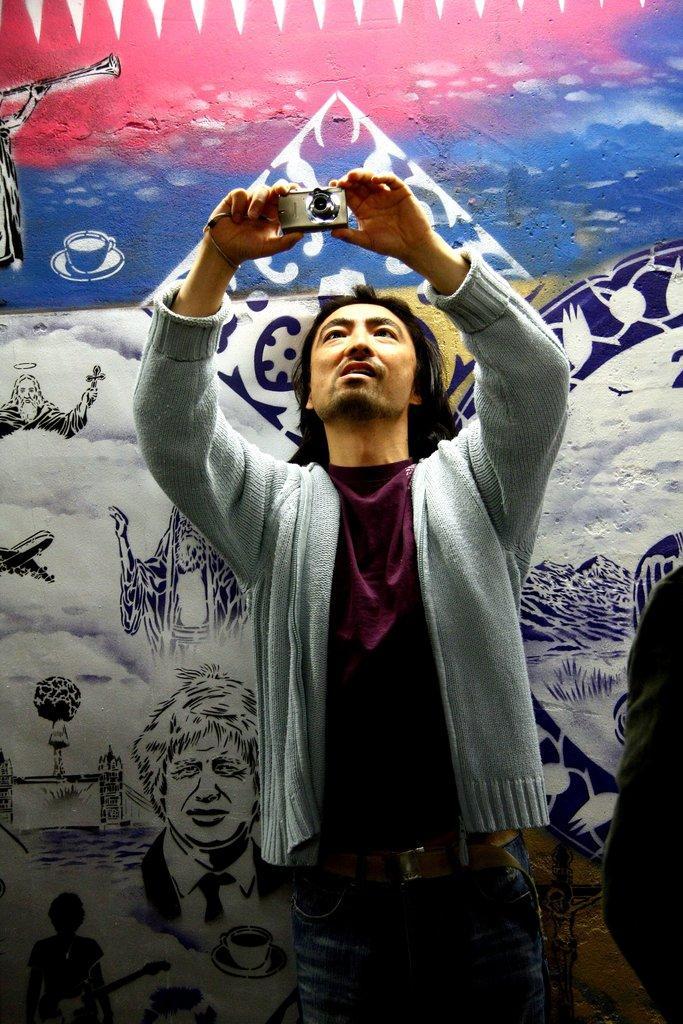Could you give a brief overview of what you see in this image? In this image there is a person standing and holding camera in his hands, in the background there is a wall, on that wall there is painting. 